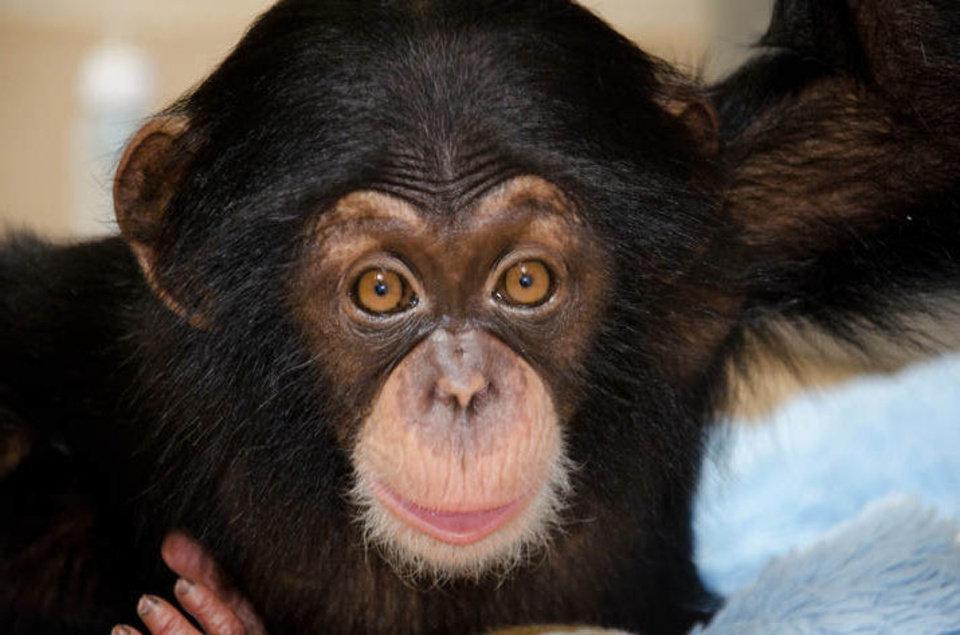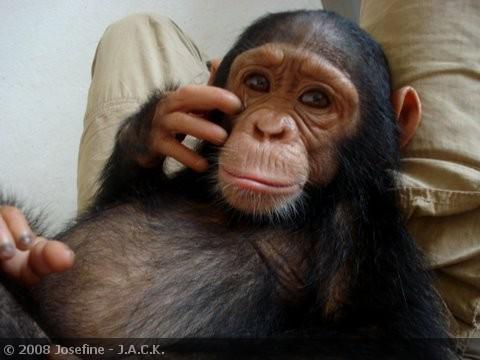The first image is the image on the left, the second image is the image on the right. For the images shown, is this caption "In one image of each pair two chimpanzees are hugging." true? Answer yes or no. No. 